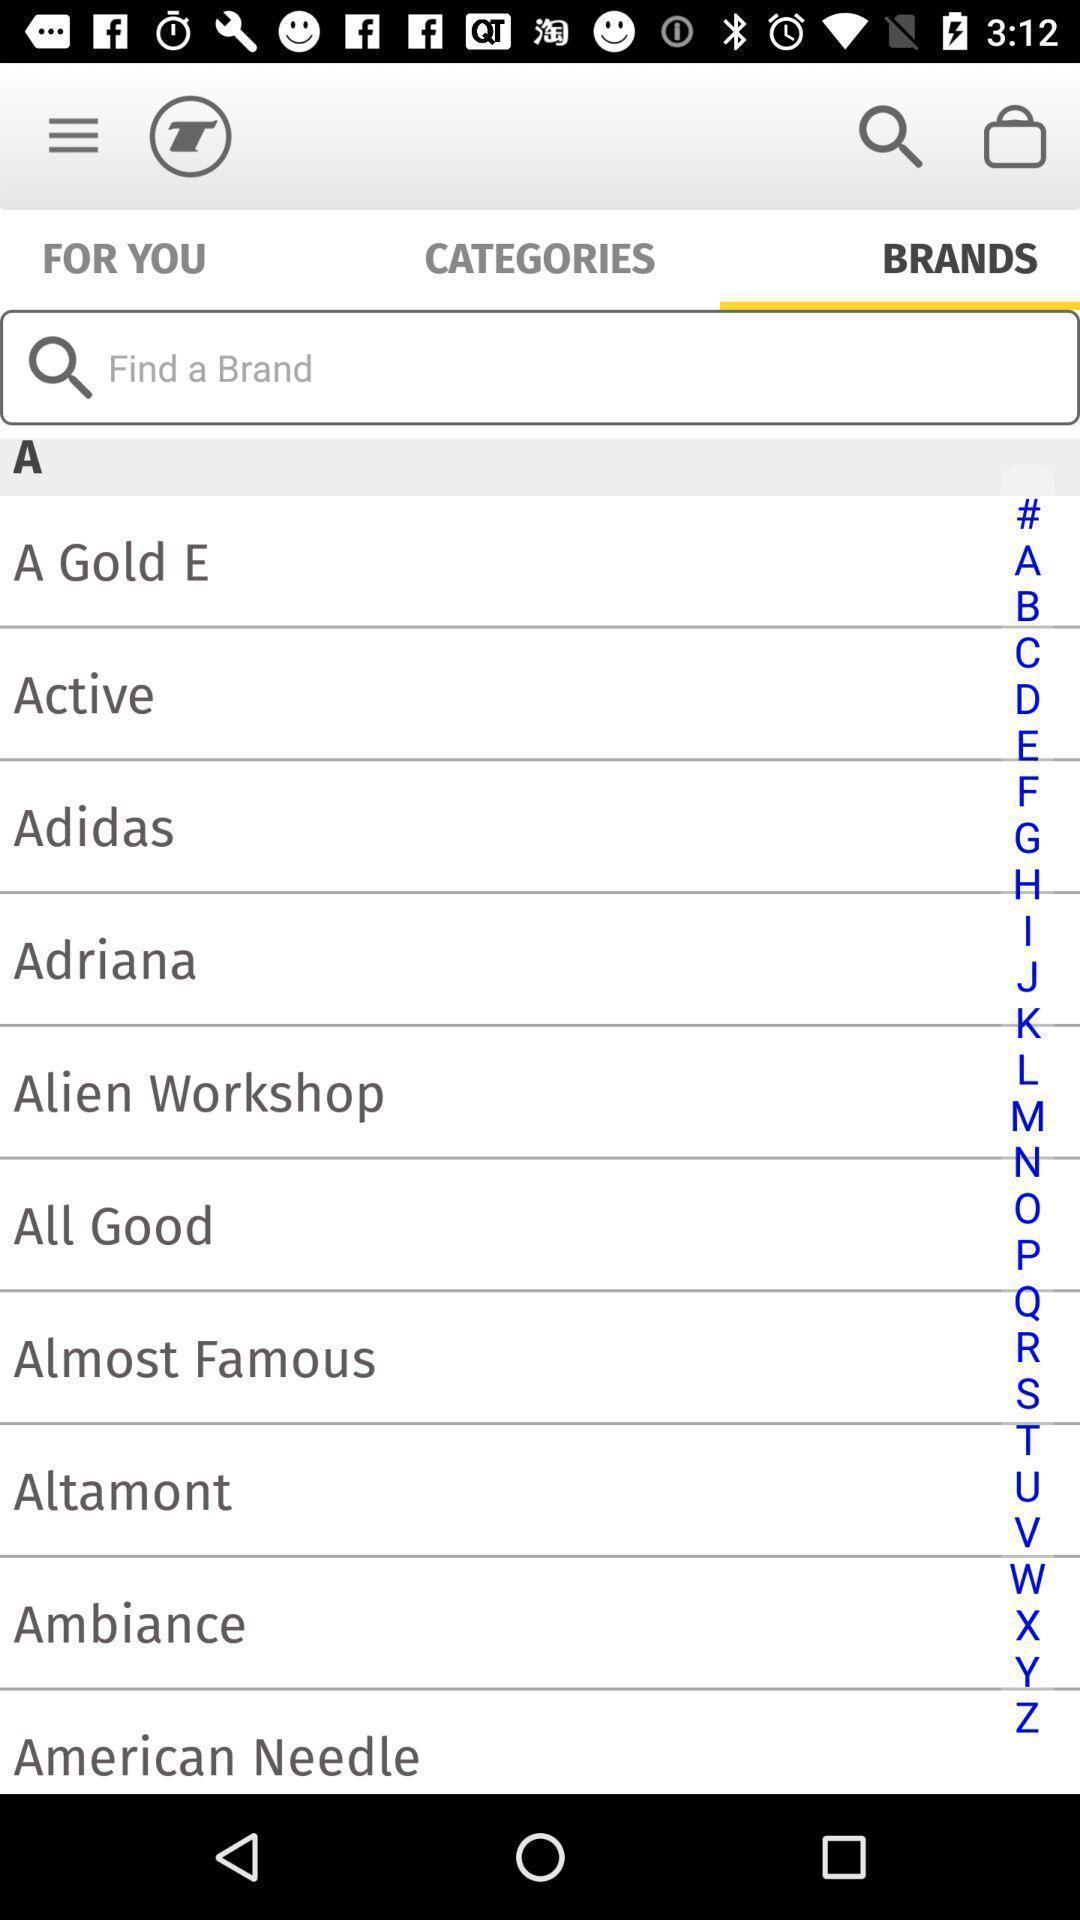Summarize the information in this screenshot. Screen displaying the list of brands. 